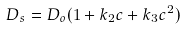Convert formula to latex. <formula><loc_0><loc_0><loc_500><loc_500>D _ { s } = D _ { o } ( 1 + k _ { 2 } c + k _ { 3 } c ^ { 2 } )</formula> 